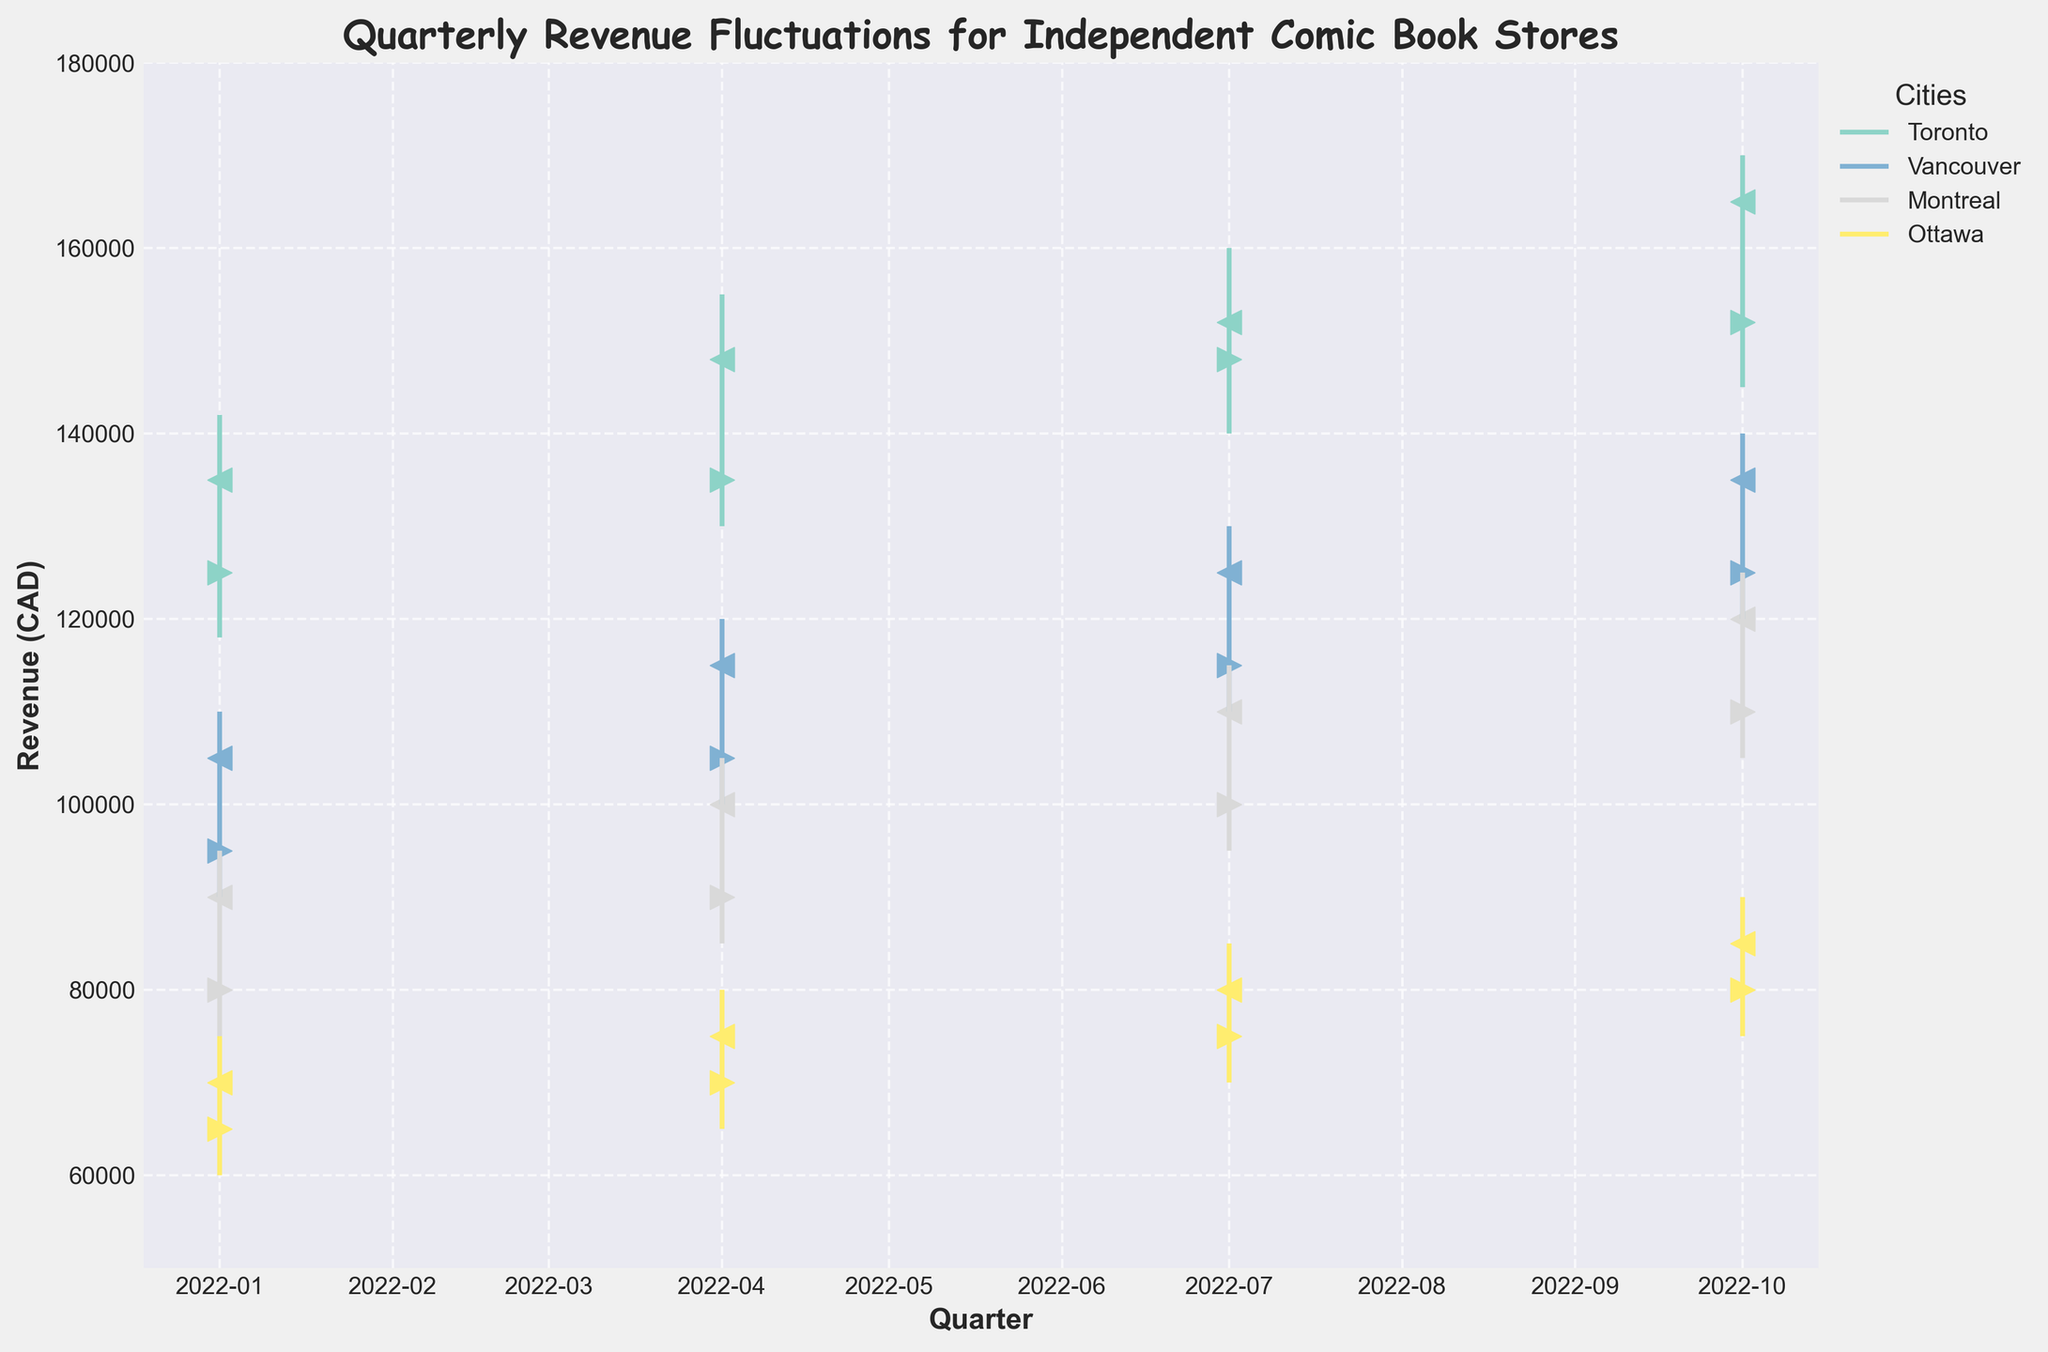What's the title of the figure? The title of the figure is clearly labeled at the top of the plot in bold, comic sans ms font style.
Answer: Quarterly Revenue Fluctuations for Independent Comic Book Stores What is the revenue range depicted in the figure? The y-axis of the plot shows the range of revenue values with a minimum of 50,000 CAD and a maximum of 180,000 CAD.
Answer: 50,000 to 180,000 CAD Which city had the highest closing revenue in Q4 2022? The closing revenue for each city in Q4 2022 can be observed from the < markers on the figure. Toronto's closing revenue is 165,000 CAD, Vancouver's is 135,000 CAD, Montreal's is 120,000 CAD, and Ottawa's is 85,000 CAD.
Answer: Toronto Which quarter had the lowest open revenue for Montreal in 2022? To find the lowest open revenue for Montreal, observe the > markers for each quarter. The open revenues are as follows: Q1 - 80,000 CAD, Q2 - 90,000 CAD, Q3 - 100,000 CAD, Q4 - 110,000 CAD. Q1 has the lowest open revenue.
Answer: Q1 2022 By how much did the closing revenue for Vancouver increase from Q1 2022 to Q4 2022? Vancouver's closing revenue in Q1 2022 was 105,000 CAD and in Q4 2022 was 135,000 CAD. The increase is calculated as 135,000 - 105,000.
Answer: 30,000 CAD What is the average closing revenue for Ottawa over the year 2022? Ottawa's closing revenues each quarter are: Q1 - 70,000 CAD, Q2 - 75,000 CAD, Q3 - 80,000 CAD, Q4 - 85,000 CAD. The average is calculated as (70,000 + 75,000 + 80,000 + 85,000) / 4.
Answer: 77,500 CAD Which city shows the most significant change in revenue between the highest and lowest points for Q4 2022? For Q4 2022, the difference between the high and low points for each city is: Toronto (170,000 - 145,000 = 25,000), Vancouver (140,000 - 120,000 = 20,000), Montreal (125,000 - 105,000 = 20,000), Ottawa (90,000 - 75,000 = 15,000). Toronto shows the most significant change.
Answer: Toronto Compare the Q2 2022 high revenue values for all cities. Which city had the highest value? The high revenue values for Q2 2022 are: Toronto - 155,000 CAD, Vancouver - 120,000 CAD, Montreal - 105,000 CAD, Ottawa - 80,000 CAD. Toronto had the highest high revenue in Q2 2022.
Answer: Toronto Between Q1 2022 and Q4 2022, which city had the smallest percentage increase in closing revenue? The percentage increases in closing revenue from Q1 2022 to Q4 2022 for each city are: Toronto (165,000 - 135,000) / 135,000 * 100 ≈ 22.22%, Vancouver (135,000 - 105,000) / 105,000 * 100 ≈ 28.57%, Montreal (120,000 - 90,000) / 90,000 * 100 ≈ 33.33%, Ottawa (85,000 - 70,000) / 70,000 * 100 ≈ 21.43%. Ottawa had the smallest percentage increase.
Answer: Ottawa 